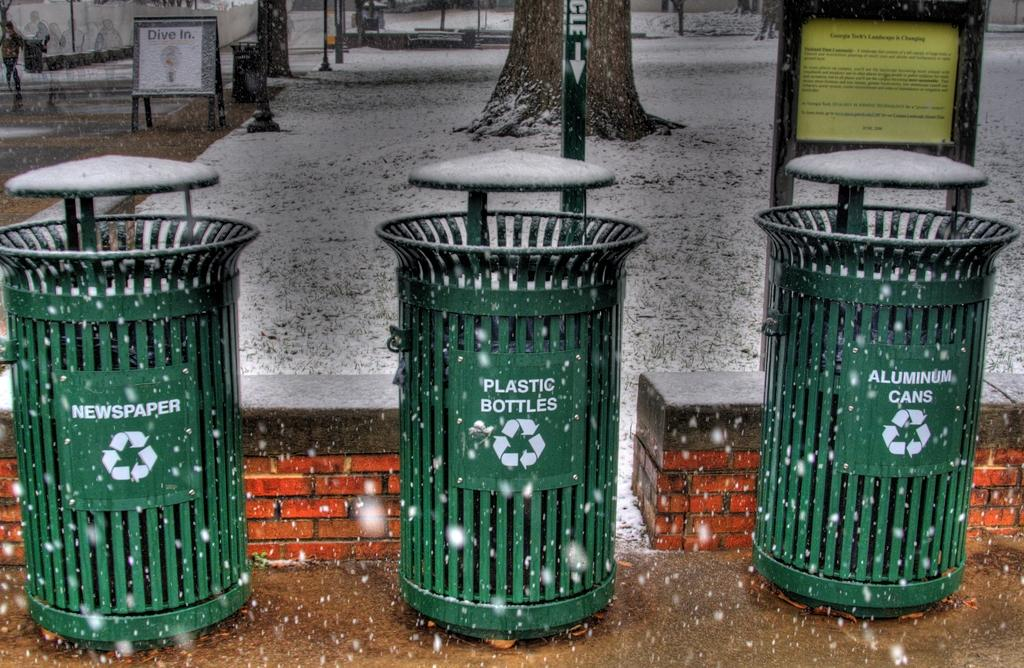Provide a one-sentence caption for the provided image. Three green trash cans are lined up for newspaper, plastic bottles, and cans. 